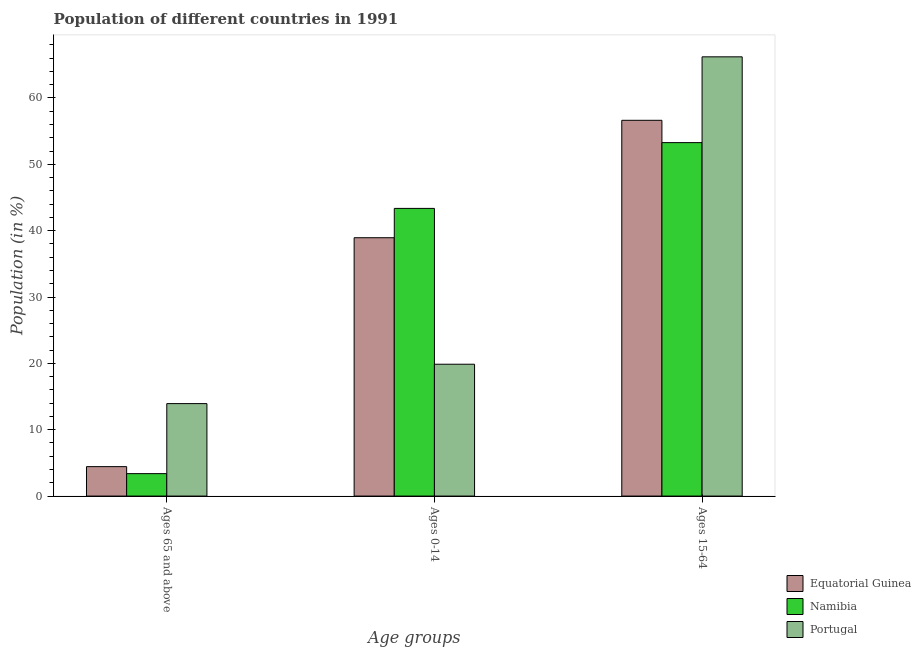How many different coloured bars are there?
Give a very brief answer. 3. Are the number of bars per tick equal to the number of legend labels?
Your response must be concise. Yes. How many bars are there on the 2nd tick from the right?
Your answer should be very brief. 3. What is the label of the 1st group of bars from the left?
Provide a short and direct response. Ages 65 and above. What is the percentage of population within the age-group 15-64 in Equatorial Guinea?
Make the answer very short. 56.63. Across all countries, what is the maximum percentage of population within the age-group of 65 and above?
Your answer should be compact. 13.94. Across all countries, what is the minimum percentage of population within the age-group 0-14?
Ensure brevity in your answer.  19.87. In which country was the percentage of population within the age-group of 65 and above maximum?
Ensure brevity in your answer.  Portugal. In which country was the percentage of population within the age-group 0-14 minimum?
Your answer should be compact. Portugal. What is the total percentage of population within the age-group 0-14 in the graph?
Keep it short and to the point. 102.16. What is the difference between the percentage of population within the age-group 15-64 in Namibia and that in Equatorial Guinea?
Your response must be concise. -3.36. What is the difference between the percentage of population within the age-group of 65 and above in Equatorial Guinea and the percentage of population within the age-group 0-14 in Namibia?
Provide a succinct answer. -38.92. What is the average percentage of population within the age-group of 65 and above per country?
Give a very brief answer. 7.25. What is the difference between the percentage of population within the age-group 0-14 and percentage of population within the age-group 15-64 in Equatorial Guinea?
Offer a terse response. -17.69. What is the ratio of the percentage of population within the age-group 15-64 in Namibia to that in Equatorial Guinea?
Offer a terse response. 0.94. Is the difference between the percentage of population within the age-group 0-14 in Portugal and Equatorial Guinea greater than the difference between the percentage of population within the age-group of 65 and above in Portugal and Equatorial Guinea?
Your answer should be compact. No. What is the difference between the highest and the second highest percentage of population within the age-group of 65 and above?
Give a very brief answer. 9.5. What is the difference between the highest and the lowest percentage of population within the age-group 0-14?
Keep it short and to the point. 23.48. In how many countries, is the percentage of population within the age-group 0-14 greater than the average percentage of population within the age-group 0-14 taken over all countries?
Ensure brevity in your answer.  2. What does the 2nd bar from the left in Ages 0-14 represents?
Make the answer very short. Namibia. What does the 2nd bar from the right in Ages 0-14 represents?
Keep it short and to the point. Namibia. Is it the case that in every country, the sum of the percentage of population within the age-group of 65 and above and percentage of population within the age-group 0-14 is greater than the percentage of population within the age-group 15-64?
Your answer should be very brief. No. Are all the bars in the graph horizontal?
Your answer should be very brief. No. How many legend labels are there?
Make the answer very short. 3. What is the title of the graph?
Your answer should be compact. Population of different countries in 1991. Does "Egypt, Arab Rep." appear as one of the legend labels in the graph?
Provide a succinct answer. No. What is the label or title of the X-axis?
Offer a very short reply. Age groups. What is the Population (in %) of Equatorial Guinea in Ages 65 and above?
Offer a terse response. 4.44. What is the Population (in %) in Namibia in Ages 65 and above?
Your answer should be compact. 3.38. What is the Population (in %) of Portugal in Ages 65 and above?
Your answer should be very brief. 13.94. What is the Population (in %) in Equatorial Guinea in Ages 0-14?
Offer a very short reply. 38.93. What is the Population (in %) in Namibia in Ages 0-14?
Give a very brief answer. 43.35. What is the Population (in %) of Portugal in Ages 0-14?
Offer a very short reply. 19.87. What is the Population (in %) of Equatorial Guinea in Ages 15-64?
Make the answer very short. 56.63. What is the Population (in %) in Namibia in Ages 15-64?
Your response must be concise. 53.27. What is the Population (in %) in Portugal in Ages 15-64?
Keep it short and to the point. 66.2. Across all Age groups, what is the maximum Population (in %) of Equatorial Guinea?
Provide a short and direct response. 56.63. Across all Age groups, what is the maximum Population (in %) in Namibia?
Your answer should be very brief. 53.27. Across all Age groups, what is the maximum Population (in %) of Portugal?
Offer a terse response. 66.2. Across all Age groups, what is the minimum Population (in %) of Equatorial Guinea?
Make the answer very short. 4.44. Across all Age groups, what is the minimum Population (in %) of Namibia?
Provide a succinct answer. 3.38. Across all Age groups, what is the minimum Population (in %) of Portugal?
Your answer should be compact. 13.94. What is the difference between the Population (in %) in Equatorial Guinea in Ages 65 and above and that in Ages 0-14?
Your answer should be compact. -34.5. What is the difference between the Population (in %) in Namibia in Ages 65 and above and that in Ages 0-14?
Your response must be concise. -39.97. What is the difference between the Population (in %) in Portugal in Ages 65 and above and that in Ages 0-14?
Give a very brief answer. -5.93. What is the difference between the Population (in %) of Equatorial Guinea in Ages 65 and above and that in Ages 15-64?
Make the answer very short. -52.19. What is the difference between the Population (in %) of Namibia in Ages 65 and above and that in Ages 15-64?
Provide a short and direct response. -49.89. What is the difference between the Population (in %) in Portugal in Ages 65 and above and that in Ages 15-64?
Your response must be concise. -52.26. What is the difference between the Population (in %) in Equatorial Guinea in Ages 0-14 and that in Ages 15-64?
Give a very brief answer. -17.69. What is the difference between the Population (in %) in Namibia in Ages 0-14 and that in Ages 15-64?
Keep it short and to the point. -9.91. What is the difference between the Population (in %) of Portugal in Ages 0-14 and that in Ages 15-64?
Ensure brevity in your answer.  -46.33. What is the difference between the Population (in %) of Equatorial Guinea in Ages 65 and above and the Population (in %) of Namibia in Ages 0-14?
Give a very brief answer. -38.92. What is the difference between the Population (in %) in Equatorial Guinea in Ages 65 and above and the Population (in %) in Portugal in Ages 0-14?
Offer a very short reply. -15.43. What is the difference between the Population (in %) in Namibia in Ages 65 and above and the Population (in %) in Portugal in Ages 0-14?
Offer a very short reply. -16.49. What is the difference between the Population (in %) in Equatorial Guinea in Ages 65 and above and the Population (in %) in Namibia in Ages 15-64?
Your response must be concise. -48.83. What is the difference between the Population (in %) of Equatorial Guinea in Ages 65 and above and the Population (in %) of Portugal in Ages 15-64?
Give a very brief answer. -61.76. What is the difference between the Population (in %) of Namibia in Ages 65 and above and the Population (in %) of Portugal in Ages 15-64?
Provide a short and direct response. -62.81. What is the difference between the Population (in %) of Equatorial Guinea in Ages 0-14 and the Population (in %) of Namibia in Ages 15-64?
Offer a very short reply. -14.33. What is the difference between the Population (in %) of Equatorial Guinea in Ages 0-14 and the Population (in %) of Portugal in Ages 15-64?
Your response must be concise. -27.26. What is the difference between the Population (in %) of Namibia in Ages 0-14 and the Population (in %) of Portugal in Ages 15-64?
Keep it short and to the point. -22.84. What is the average Population (in %) of Equatorial Guinea per Age groups?
Give a very brief answer. 33.33. What is the average Population (in %) in Namibia per Age groups?
Give a very brief answer. 33.33. What is the average Population (in %) of Portugal per Age groups?
Offer a terse response. 33.33. What is the difference between the Population (in %) of Equatorial Guinea and Population (in %) of Namibia in Ages 65 and above?
Keep it short and to the point. 1.06. What is the difference between the Population (in %) of Equatorial Guinea and Population (in %) of Portugal in Ages 65 and above?
Make the answer very short. -9.5. What is the difference between the Population (in %) in Namibia and Population (in %) in Portugal in Ages 65 and above?
Offer a terse response. -10.55. What is the difference between the Population (in %) of Equatorial Guinea and Population (in %) of Namibia in Ages 0-14?
Make the answer very short. -4.42. What is the difference between the Population (in %) in Equatorial Guinea and Population (in %) in Portugal in Ages 0-14?
Your response must be concise. 19.06. What is the difference between the Population (in %) in Namibia and Population (in %) in Portugal in Ages 0-14?
Make the answer very short. 23.48. What is the difference between the Population (in %) in Equatorial Guinea and Population (in %) in Namibia in Ages 15-64?
Ensure brevity in your answer.  3.36. What is the difference between the Population (in %) in Equatorial Guinea and Population (in %) in Portugal in Ages 15-64?
Your response must be concise. -9.57. What is the difference between the Population (in %) in Namibia and Population (in %) in Portugal in Ages 15-64?
Your response must be concise. -12.93. What is the ratio of the Population (in %) in Equatorial Guinea in Ages 65 and above to that in Ages 0-14?
Give a very brief answer. 0.11. What is the ratio of the Population (in %) in Namibia in Ages 65 and above to that in Ages 0-14?
Offer a very short reply. 0.08. What is the ratio of the Population (in %) in Portugal in Ages 65 and above to that in Ages 0-14?
Keep it short and to the point. 0.7. What is the ratio of the Population (in %) in Equatorial Guinea in Ages 65 and above to that in Ages 15-64?
Offer a very short reply. 0.08. What is the ratio of the Population (in %) in Namibia in Ages 65 and above to that in Ages 15-64?
Ensure brevity in your answer.  0.06. What is the ratio of the Population (in %) in Portugal in Ages 65 and above to that in Ages 15-64?
Your response must be concise. 0.21. What is the ratio of the Population (in %) in Equatorial Guinea in Ages 0-14 to that in Ages 15-64?
Offer a very short reply. 0.69. What is the ratio of the Population (in %) in Namibia in Ages 0-14 to that in Ages 15-64?
Provide a succinct answer. 0.81. What is the ratio of the Population (in %) in Portugal in Ages 0-14 to that in Ages 15-64?
Ensure brevity in your answer.  0.3. What is the difference between the highest and the second highest Population (in %) in Equatorial Guinea?
Make the answer very short. 17.69. What is the difference between the highest and the second highest Population (in %) in Namibia?
Provide a short and direct response. 9.91. What is the difference between the highest and the second highest Population (in %) of Portugal?
Ensure brevity in your answer.  46.33. What is the difference between the highest and the lowest Population (in %) in Equatorial Guinea?
Offer a terse response. 52.19. What is the difference between the highest and the lowest Population (in %) in Namibia?
Your answer should be very brief. 49.89. What is the difference between the highest and the lowest Population (in %) of Portugal?
Keep it short and to the point. 52.26. 